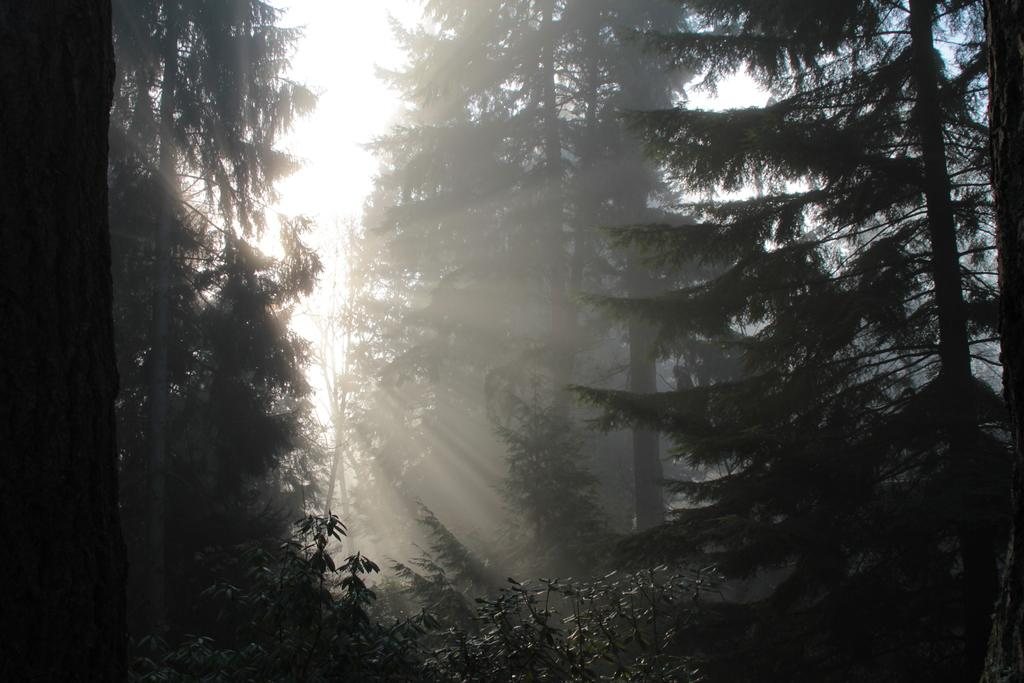What type of vegetation can be seen in the image? There are trees in the image. What part of the natural environment is visible in the image? The sky is visible in the background of the image. How many feet are visible in the image? There are no feet visible in the image; it features trees and the sky. What type of bit is being used by the trees in the image? There is no bit present in the image; it features trees and the sky. 